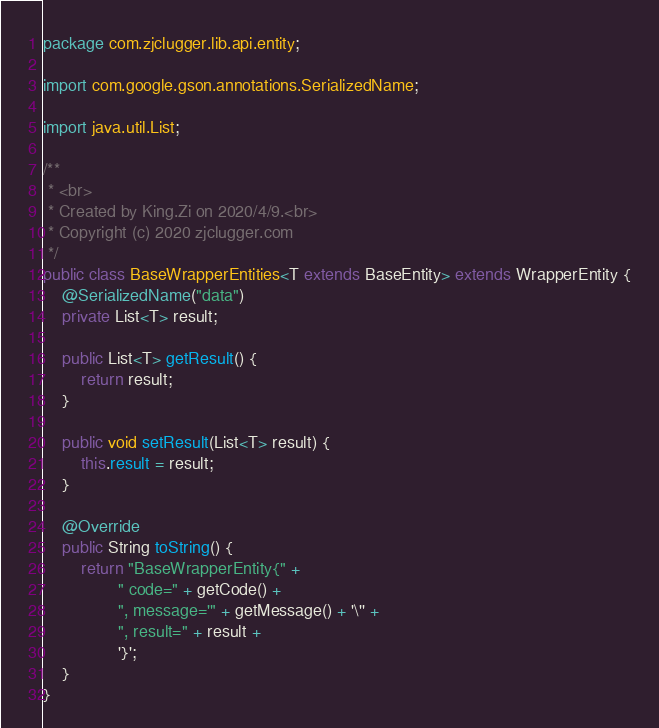<code> <loc_0><loc_0><loc_500><loc_500><_Java_>package com.zjclugger.lib.api.entity;

import com.google.gson.annotations.SerializedName;

import java.util.List;

/**
 * <br>
 * Created by King.Zi on 2020/4/9.<br>
 * Copyright (c) 2020 zjclugger.com
 */
public class BaseWrapperEntities<T extends BaseEntity> extends WrapperEntity {
    @SerializedName("data")
    private List<T> result;

    public List<T> getResult() {
        return result;
    }

    public void setResult(List<T> result) {
        this.result = result;
    }

    @Override
    public String toString() {
        return "BaseWrapperEntity{" +
                " code=" + getCode() +
                ", message='" + getMessage() + '\'' +
                ", result=" + result +
                '}';
    }
}
</code> 